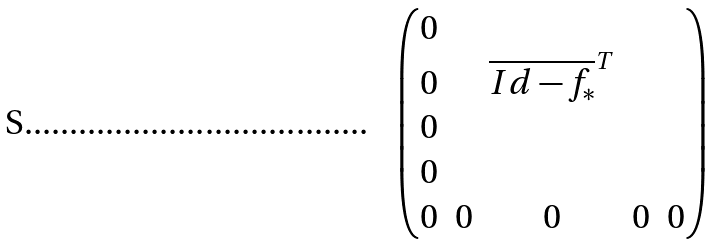Convert formula to latex. <formula><loc_0><loc_0><loc_500><loc_500>\begin{pmatrix} 0 & & & & \\ 0 & & \overline { I d - f _ { * } } ^ { T } & & \\ 0 & & & & \\ 0 & & & & \\ 0 & 0 & 0 & 0 & 0 \end{pmatrix}</formula> 